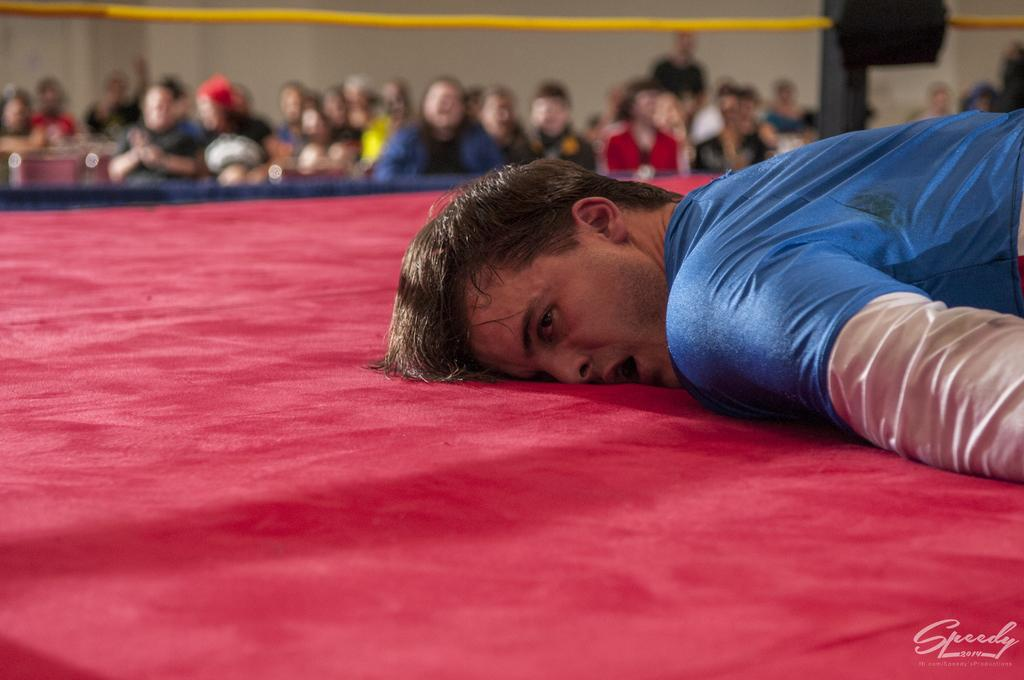What is the main subject of the image? There is a person lying on a stage in the image. Can you describe the people in the background? There are people standing in the background of the image. How is the background of the image depicted? The background is blurred. What type of reaction can be seen from the audience in the image? There is no audience present in the image, only people standing in the background. How many songs are being performed by the person lying on the stage in the image? The image does not provide information about the number of songs being performed. 